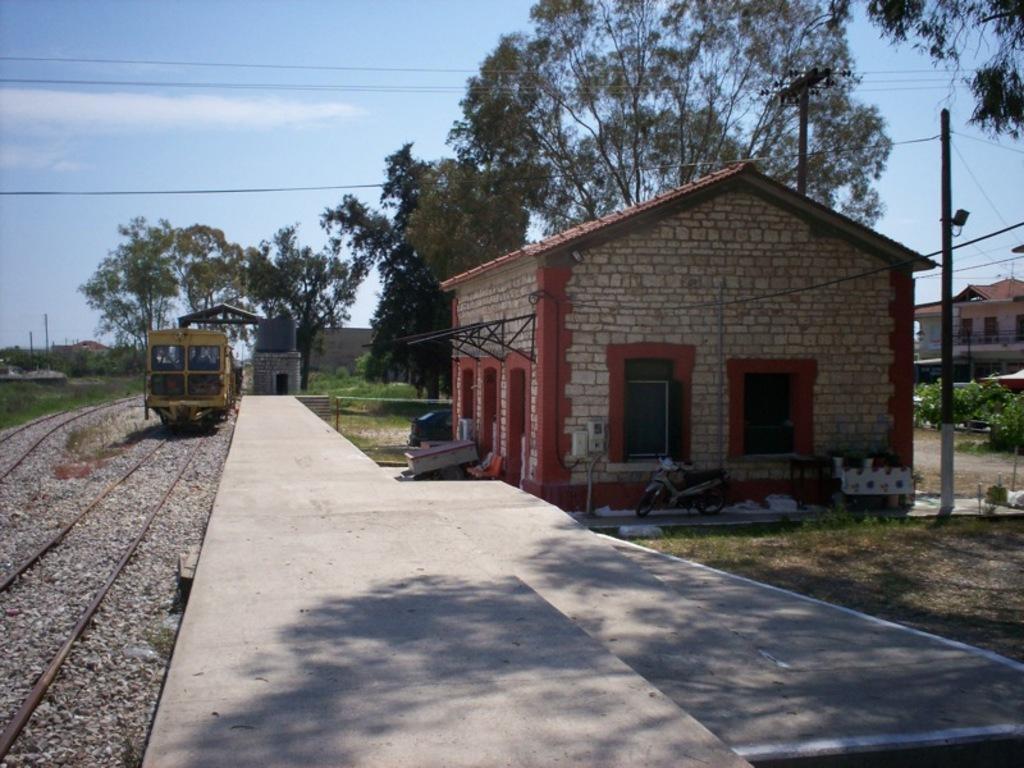Please provide a concise description of this image. In the image there is a train on the track over left side with a platform in the middle and a home on the right side followed by trees behind it and above its sky with clouds. 